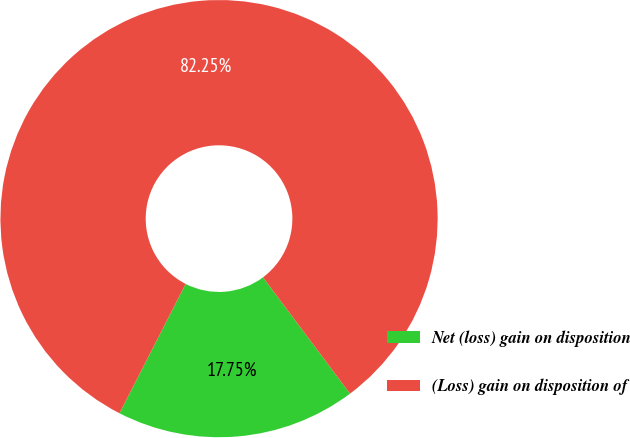Convert chart. <chart><loc_0><loc_0><loc_500><loc_500><pie_chart><fcel>Net (loss) gain on disposition<fcel>(Loss) gain on disposition of<nl><fcel>17.75%<fcel>82.25%<nl></chart> 